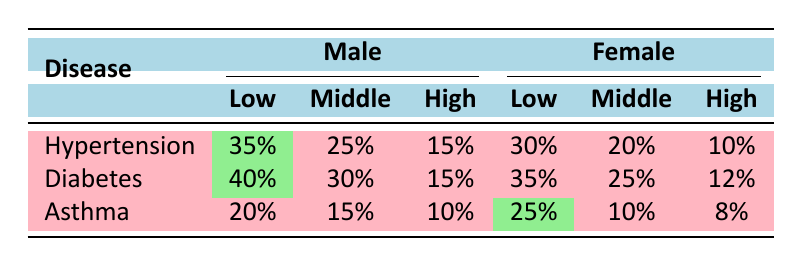What is the prevalence percentage of Hypertension among low socioeconomic status males? The table shows that the prevalence of Hypertension for males in the low socioeconomic status category is highlighted, which is 35%.
Answer: 35% What is the prevalence percentage of Asthma among high socioeconomic status females? Looking at the table, the prevalence of Asthma for females in the high socioeconomic status category is 8%.
Answer: 8% Which chronic disease has the highest prevalence among low socioeconomic status females? By comparing the prevalence percentages of all diseases in the low socioeconomic status category for females, Diabetes has the highest prevalence at 35%.
Answer: Diabetes What is the difference in prevalence percentages of Hypertension between low and middle socioeconomic status males? The prevalence percentage of Hypertension for low socioeconomic status males is 35%, and for middle, it is 25%. The difference is calculated as 35% - 25% = 10%.
Answer: 10% What are the average prevalence percentages of Diabetes for males and females in middle socioeconomic status? For males, the prevalence of Diabetes in middle socioeconomic status is 30%, and for females, it is 25%. The average is calculated as (30% + 25%) / 2 = 27.5%.
Answer: 27.5% Is the prevalence percentage of Asthma higher for females in low socioeconomic status than for males in high socioeconomic status? The prevalence percentage of Asthma for females in low socioeconomic status is 25%, while for males in high socioeconomic status, it is 10%. Since 25% > 10%, the statement is true.
Answer: Yes Which gender has a higher prevalence of Diabetes in the low socioeconomic status category? For low socioeconomic status, males have a prevalence of 40% for Diabetes, while females have 35%. Since 40% > 35%, males have a higher prevalence.
Answer: Males What is the total prevalence percentage of Hypertension for males across all socioeconomic statuses? The prevalence percentages for males in Hypertension are 35% (low) + 25% (middle) + 15% (high), which totals to 35% + 25% + 15% = 75%.
Answer: 75% 